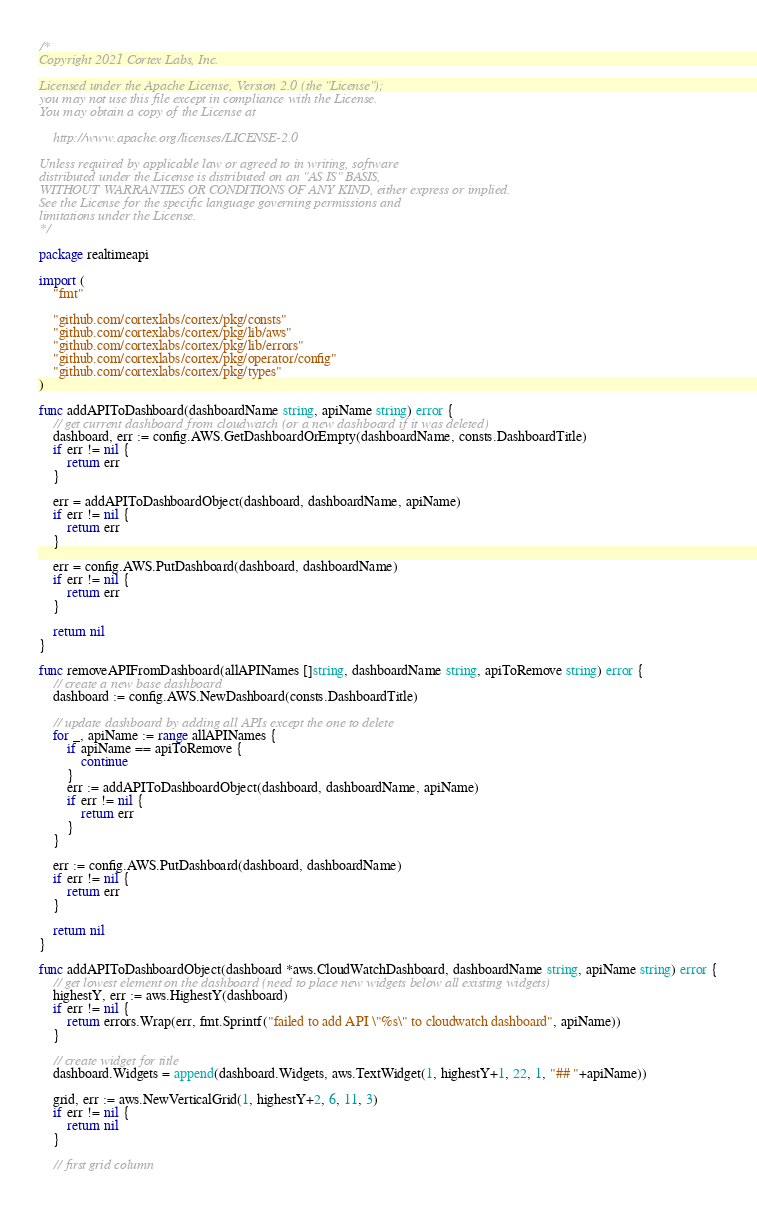Convert code to text. <code><loc_0><loc_0><loc_500><loc_500><_Go_>/*
Copyright 2021 Cortex Labs, Inc.

Licensed under the Apache License, Version 2.0 (the "License");
you may not use this file except in compliance with the License.
You may obtain a copy of the License at

    http://www.apache.org/licenses/LICENSE-2.0

Unless required by applicable law or agreed to in writing, software
distributed under the License is distributed on an "AS IS" BASIS,
WITHOUT WARRANTIES OR CONDITIONS OF ANY KIND, either express or implied.
See the License for the specific language governing permissions and
limitations under the License.
*/

package realtimeapi

import (
	"fmt"

	"github.com/cortexlabs/cortex/pkg/consts"
	"github.com/cortexlabs/cortex/pkg/lib/aws"
	"github.com/cortexlabs/cortex/pkg/lib/errors"
	"github.com/cortexlabs/cortex/pkg/operator/config"
	"github.com/cortexlabs/cortex/pkg/types"
)

func addAPIToDashboard(dashboardName string, apiName string) error {
	// get current dashboard from cloudwatch (or a new dashboard if it was deleted)
	dashboard, err := config.AWS.GetDashboardOrEmpty(dashboardName, consts.DashboardTitle)
	if err != nil {
		return err
	}

	err = addAPIToDashboardObject(dashboard, dashboardName, apiName)
	if err != nil {
		return err
	}

	err = config.AWS.PutDashboard(dashboard, dashboardName)
	if err != nil {
		return err
	}

	return nil
}

func removeAPIFromDashboard(allAPINames []string, dashboardName string, apiToRemove string) error {
	// create a new base dashboard
	dashboard := config.AWS.NewDashboard(consts.DashboardTitle)

	// update dashboard by adding all APIs except the one to delete
	for _, apiName := range allAPINames {
		if apiName == apiToRemove {
			continue
		}
		err := addAPIToDashboardObject(dashboard, dashboardName, apiName)
		if err != nil {
			return err
		}
	}

	err := config.AWS.PutDashboard(dashboard, dashboardName)
	if err != nil {
		return err
	}

	return nil
}

func addAPIToDashboardObject(dashboard *aws.CloudWatchDashboard, dashboardName string, apiName string) error {
	// get lowest element on the dashboard (need to place new widgets below all existing widgets)
	highestY, err := aws.HighestY(dashboard)
	if err != nil {
		return errors.Wrap(err, fmt.Sprintf("failed to add API \"%s\" to cloudwatch dashboard", apiName))
	}

	// create widget for title
	dashboard.Widgets = append(dashboard.Widgets, aws.TextWidget(1, highestY+1, 22, 1, "## "+apiName))

	grid, err := aws.NewVerticalGrid(1, highestY+2, 6, 11, 3)
	if err != nil {
		return nil
	}

	// first grid column</code> 